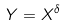<formula> <loc_0><loc_0><loc_500><loc_500>Y = X ^ { \delta }</formula> 